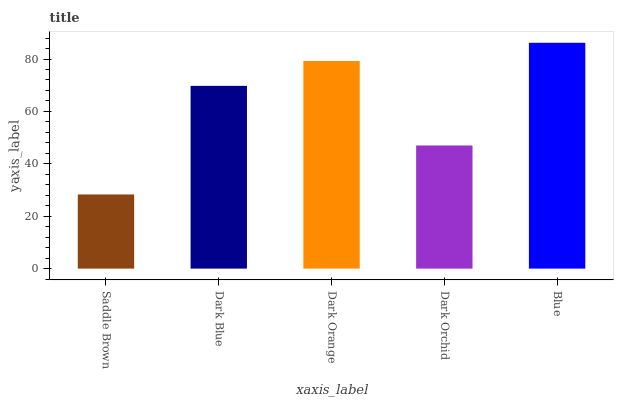Is Saddle Brown the minimum?
Answer yes or no. Yes. Is Blue the maximum?
Answer yes or no. Yes. Is Dark Blue the minimum?
Answer yes or no. No. Is Dark Blue the maximum?
Answer yes or no. No. Is Dark Blue greater than Saddle Brown?
Answer yes or no. Yes. Is Saddle Brown less than Dark Blue?
Answer yes or no. Yes. Is Saddle Brown greater than Dark Blue?
Answer yes or no. No. Is Dark Blue less than Saddle Brown?
Answer yes or no. No. Is Dark Blue the high median?
Answer yes or no. Yes. Is Dark Blue the low median?
Answer yes or no. Yes. Is Saddle Brown the high median?
Answer yes or no. No. Is Blue the low median?
Answer yes or no. No. 